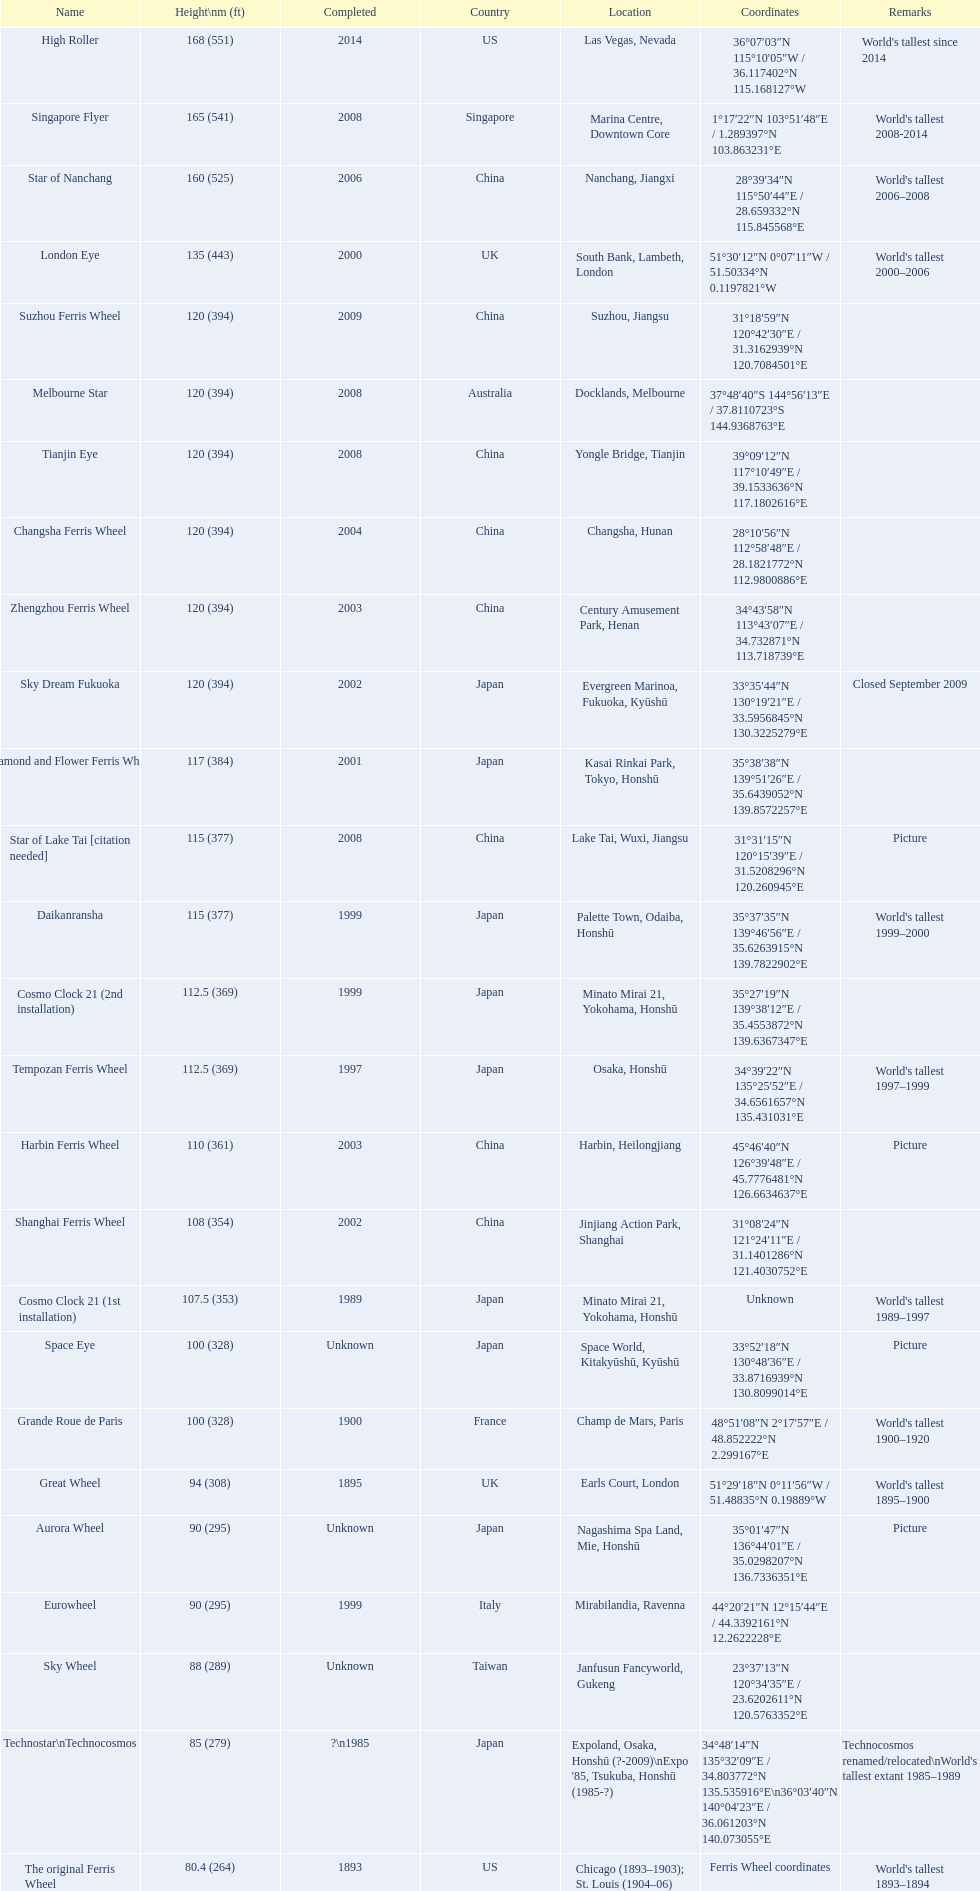How high is the star of nanchang roller coaster? 165 (541). When was the construction of the star of nanchang roller coaster completed? 2008. What is the name of the earliest roller coaster? Star of Nanchang. 